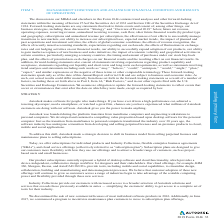According to Autodesk's financial document, What was the cash flow from operations in 2019? Based on the financial document, the answer is $377.1 (in millions). Also, can you calculate: What was the company's total liabilities in 2018? Based on the calculation: 4,113.6- (-256) , the result is 4369.6 (in millions). The key data points involved are: 256, 4,113.6. Also, can you calculate: What is the year-on-year percentage change in cash flow from operations from 2018 to 2019? To answer this question, I need to perform calculations using the financial data. The calculation is: (377.1-0.9)/0.9  , which equals 41800 (percentage). The key data points involved are: 0.9, 377.1. Also, What other statements or information should be read together with the financial table? Based on the financial document, the answer is Item 7, “Management's Discussion and Analysis of Financial Condition and Results of Operations,” and the consolidated financial statements and related notes thereto included in Item 8 of this Form 10-K. Also, What is the net revenue for the fiscal year 2017? Based on the financial document, the answer is $2,031.0 (in millions). Also, can you calculate: What is the average net income from 2015 to 2019? To answer this question, I need to perform calculations using the financial data. The calculation is: $(-80.8-566.9-582.1-330.5+81.8)/5 , which equals -295.7 (in millions). The key data points involved are: 330.5, 566.9, 582.1. 